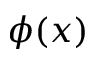Convert formula to latex. <formula><loc_0><loc_0><loc_500><loc_500>\phi ( x )</formula> 